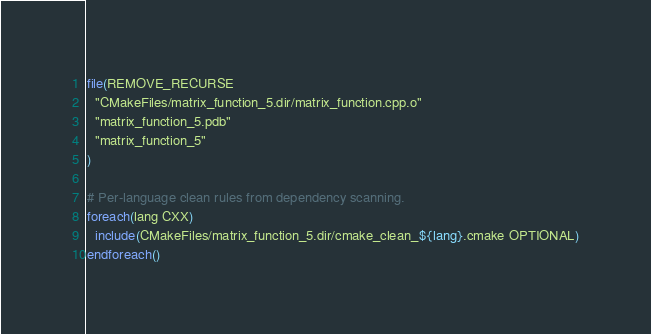Convert code to text. <code><loc_0><loc_0><loc_500><loc_500><_CMake_>file(REMOVE_RECURSE
  "CMakeFiles/matrix_function_5.dir/matrix_function.cpp.o"
  "matrix_function_5.pdb"
  "matrix_function_5"
)

# Per-language clean rules from dependency scanning.
foreach(lang CXX)
  include(CMakeFiles/matrix_function_5.dir/cmake_clean_${lang}.cmake OPTIONAL)
endforeach()
</code> 